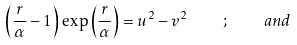Convert formula to latex. <formula><loc_0><loc_0><loc_500><loc_500>\left ( \frac { r } { \alpha } - 1 \right ) \, \exp \left ( \frac { r } { \alpha } \right ) = u ^ { 2 } - v ^ { 2 } \quad ; \quad a n d</formula> 